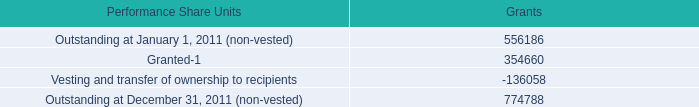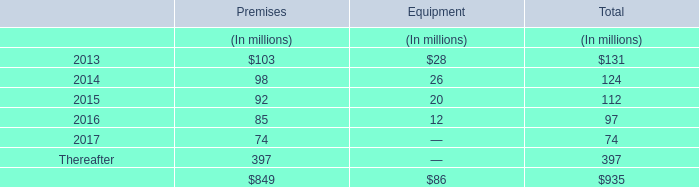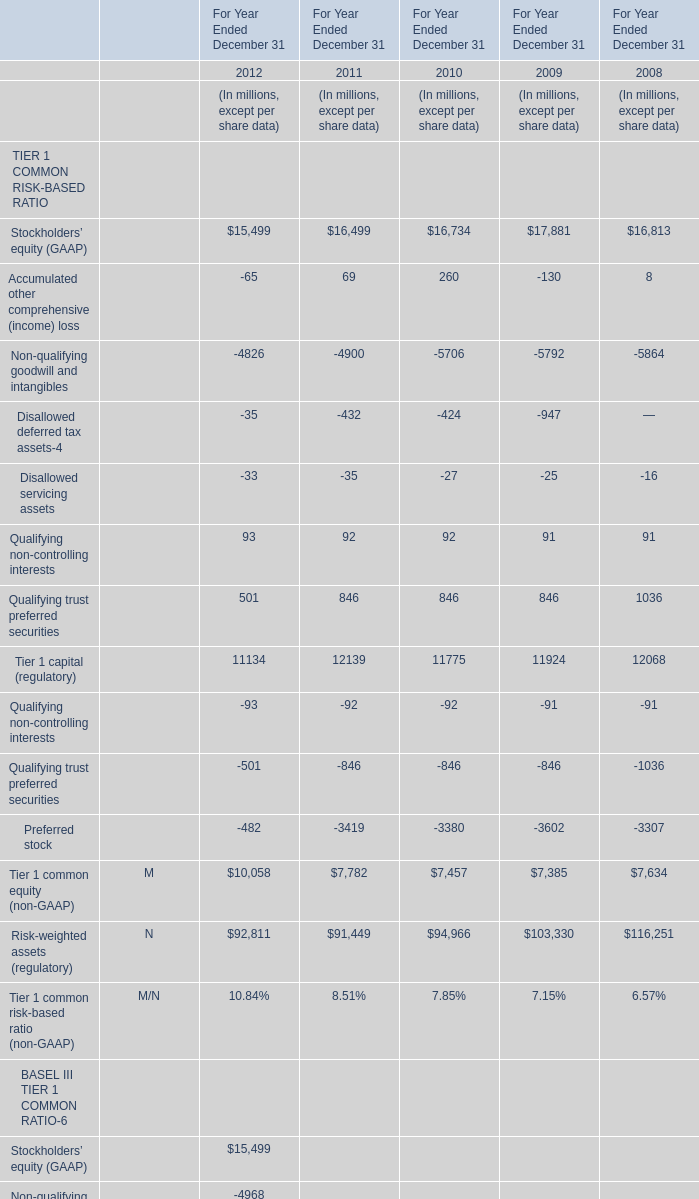What is the sum of the Preferred stock in the years where Accumulated other comprehensive (income) loss greater than 0 ? (in million) 
Computations: ((-3419 - 3380) - 3307)
Answer: -10106.0. 